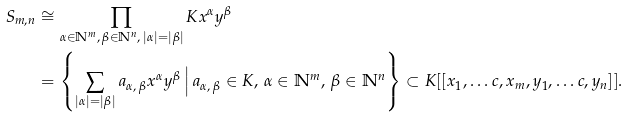Convert formula to latex. <formula><loc_0><loc_0><loc_500><loc_500>S _ { m , n } & \cong \prod _ { \alpha \in \mathbb { N } ^ { m } , \, \beta \in \mathbb { N } ^ { n } , \, | \alpha | = | \beta | } K x ^ { \alpha } y ^ { \beta } \\ & = \left \{ \sum _ { | \alpha | = | \beta | } a _ { \alpha , \, \beta } x ^ { \alpha } y ^ { \beta } \, \Big | \, a _ { \alpha , \, \beta } \in K , \, \alpha \in \mathbb { N } ^ { m } , \, \beta \in \mathbb { N } ^ { n } \right \} \subset K [ [ x _ { 1 } , \dots c , x _ { m } , y _ { 1 } , \dots c , y _ { n } ] ] .</formula> 